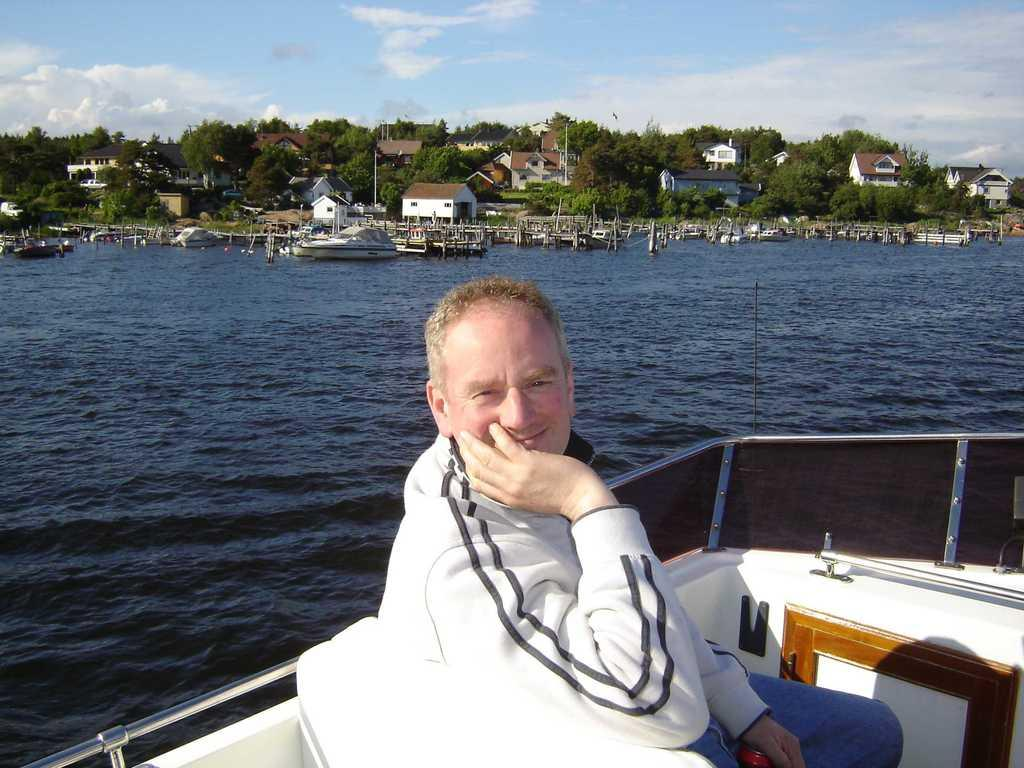What is the man in the foreground of the image wearing? The man in the foreground of the image is wearing a white coat. Where is the man located in the image? The man is on a boat in the image. What can be seen in the background of the image? In the background of the image, there is water, buildings, trees, and the sky. Can you describe the sky in the image? The sky in the image is visible and has a cloud. What type of spring can be seen on the boat in the image? There is no spring visible on the boat in the image. How does the man in the white coat shake hands with the person on the shore? There is no person on the shore in the image, so the man in the white coat cannot shake hands with anyone. 